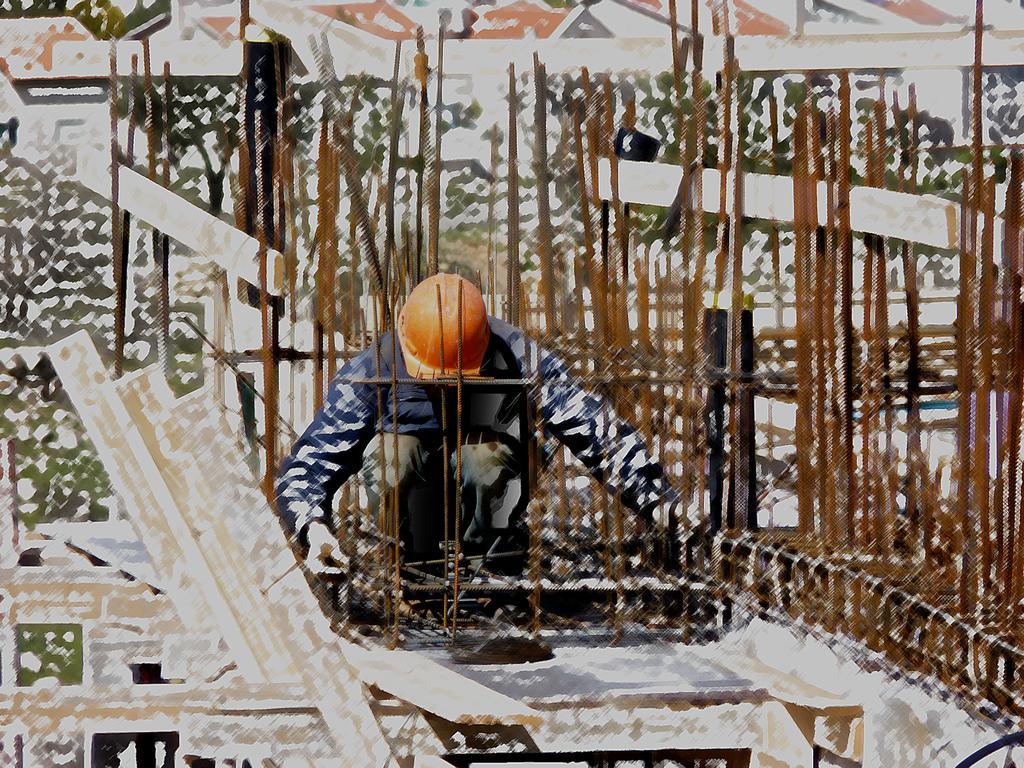Can you describe this image briefly? This image is an edited image. In the middle of the image there is a man and there are few iron bars. This image is a little blurred. 